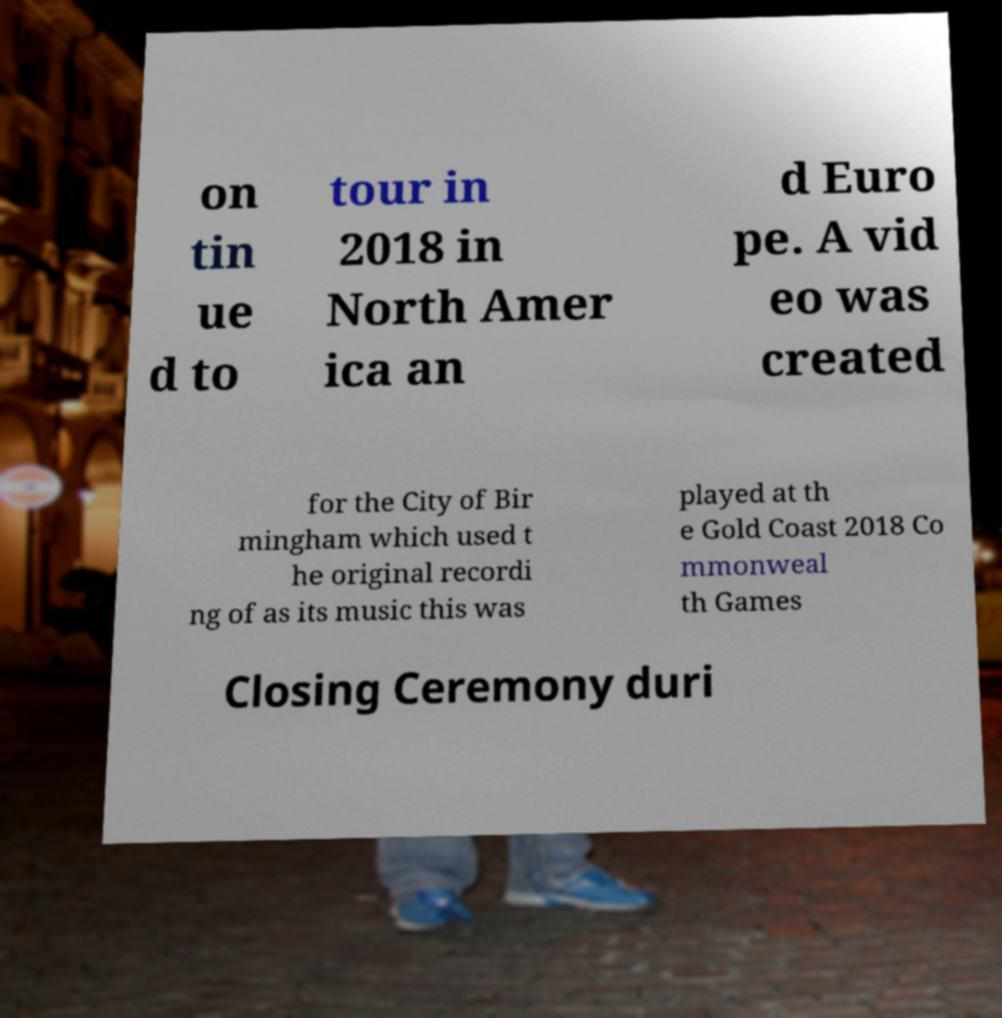Please read and relay the text visible in this image. What does it say? on tin ue d to tour in 2018 in North Amer ica an d Euro pe. A vid eo was created for the City of Bir mingham which used t he original recordi ng of as its music this was played at th e Gold Coast 2018 Co mmonweal th Games Closing Ceremony duri 